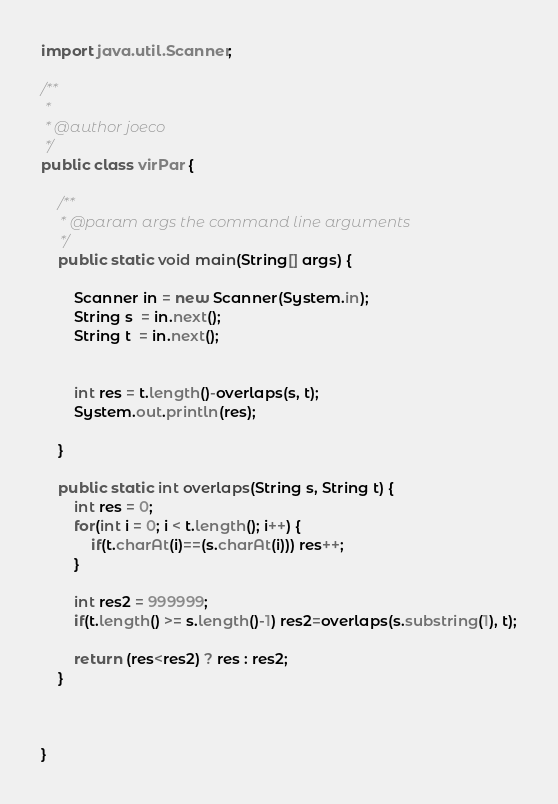Convert code to text. <code><loc_0><loc_0><loc_500><loc_500><_Java_>import java.util.Scanner;

/**
 *
 * @author joeco
 */
public class virPar {

    /**
     * @param args the command line arguments
     */
    public static void main(String[] args) {
        
        Scanner in = new Scanner(System.in);
        String s  = in.next();
        String t  = in.next();
        
        
        int res = t.length()-overlaps(s, t);
        System.out.println(res);
        
    }
    
    public static int overlaps(String s, String t) {
        int res = 0;
        for(int i = 0; i < t.length(); i++) {
            if(t.charAt(i)==(s.charAt(i))) res++;
        }
        
        int res2 = 999999;
        if(t.length() >= s.length()-1) res2=overlaps(s.substring(1), t);
        
        return (res<res2) ? res : res2;
    }
    
    
    
}</code> 